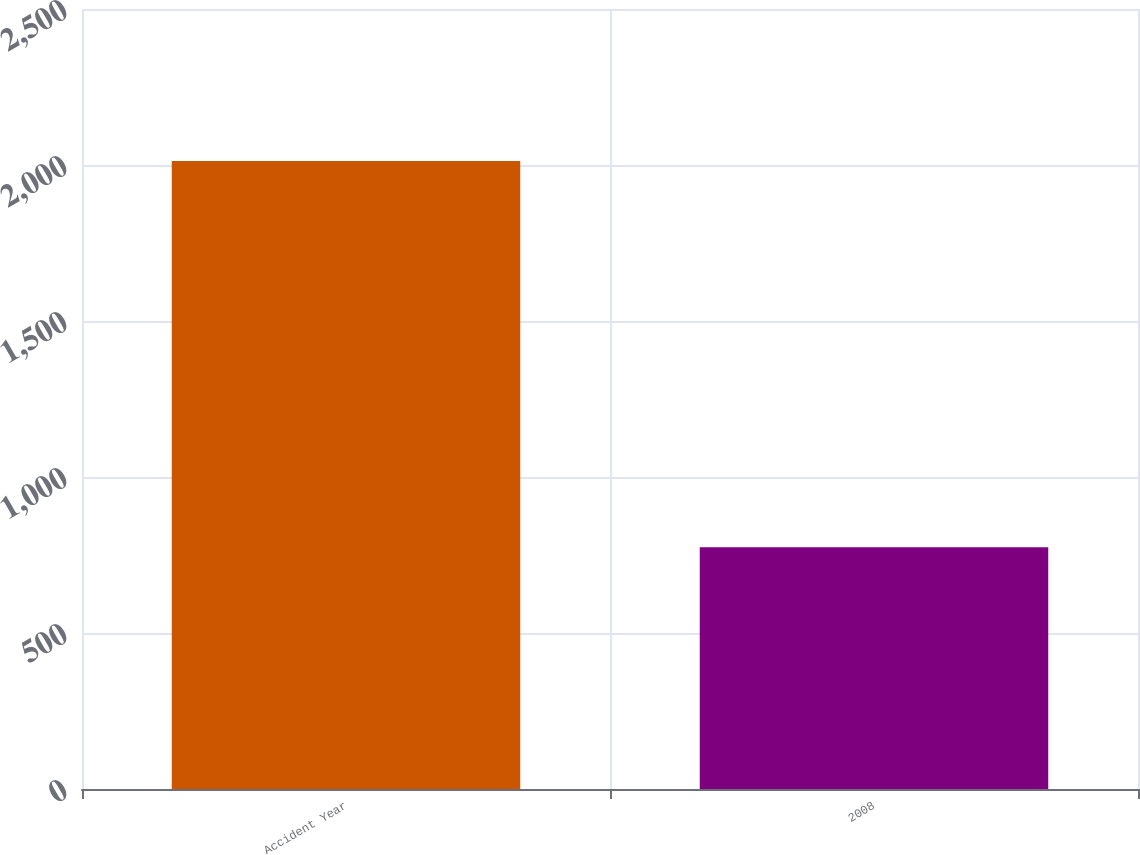<chart> <loc_0><loc_0><loc_500><loc_500><bar_chart><fcel>Accident Year<fcel>2008<nl><fcel>2013<fcel>775<nl></chart> 